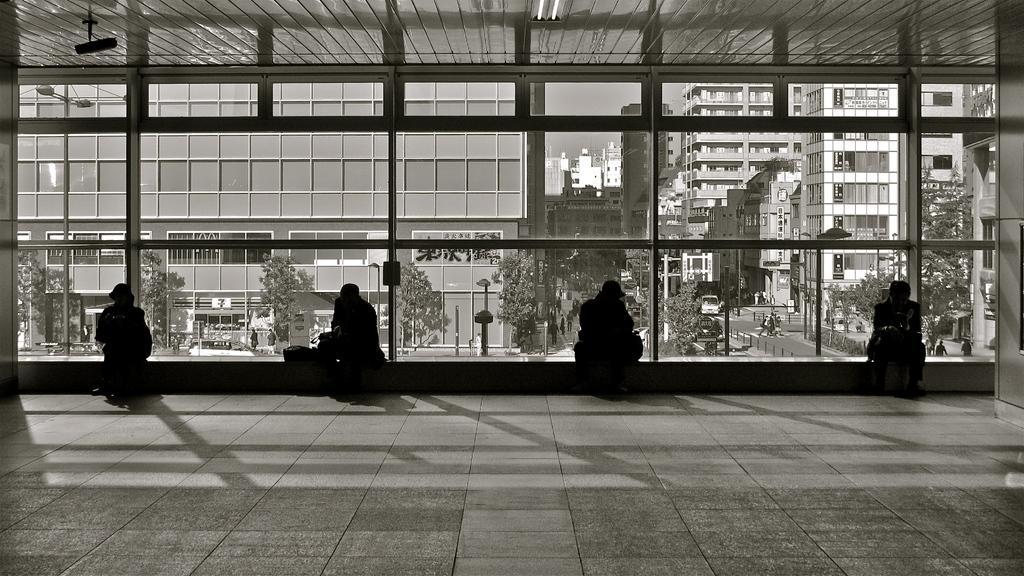In one or two sentences, can you explain what this image depicts? In this picture we can see four persons sitting here, in the background there are some buildings, trees and poles, we can see a vehicle here, we can see glass here. 